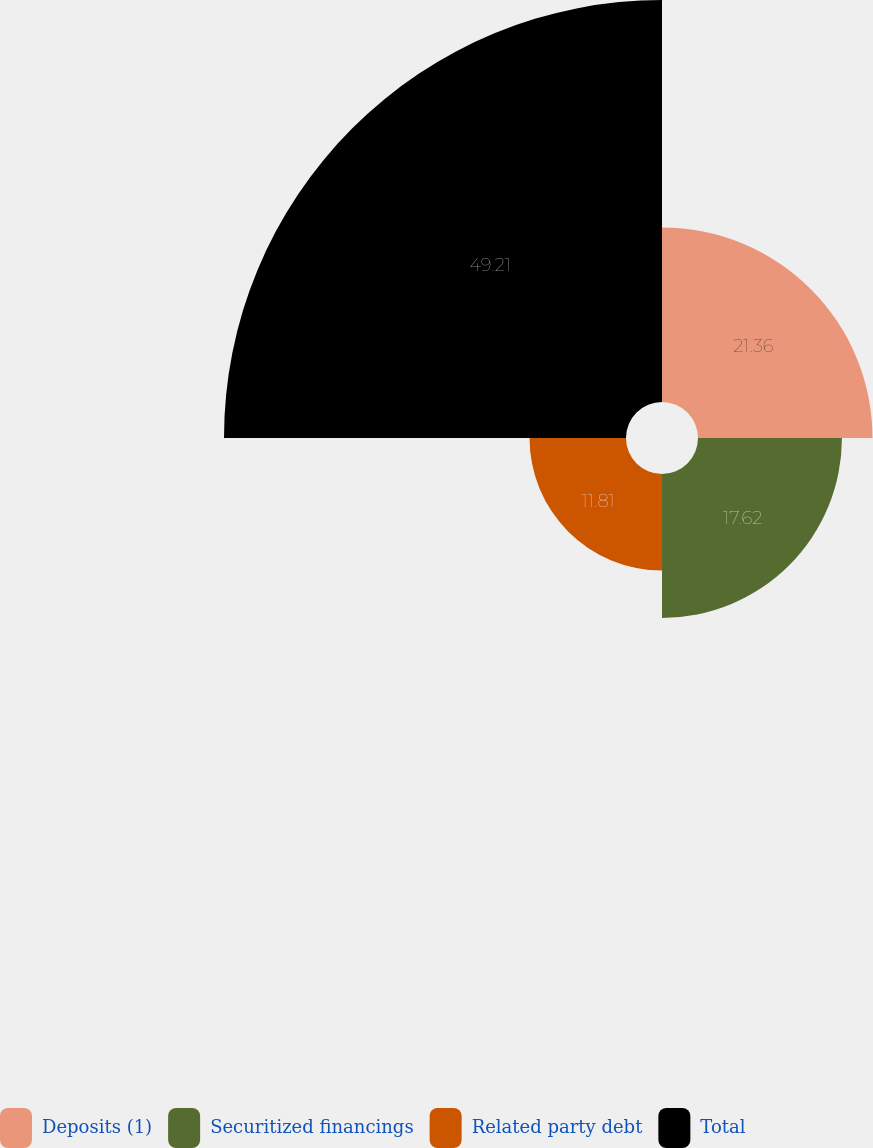Convert chart. <chart><loc_0><loc_0><loc_500><loc_500><pie_chart><fcel>Deposits (1)<fcel>Securitized financings<fcel>Related party debt<fcel>Total<nl><fcel>21.36%<fcel>17.62%<fcel>11.81%<fcel>49.21%<nl></chart> 